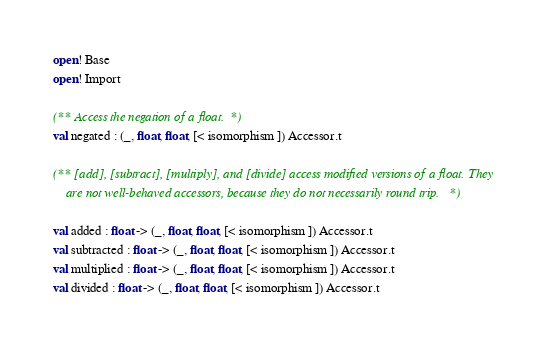<code> <loc_0><loc_0><loc_500><loc_500><_OCaml_>open! Base
open! Import

(** Access the negation of a float. *)
val negated : (_, float, float, [< isomorphism ]) Accessor.t

(** [add], [subtract], [multiply], and [divide] access modified versions of a float. They
    are not well-behaved accessors, because they do not necessarily round trip. *)

val added : float -> (_, float, float, [< isomorphism ]) Accessor.t
val subtracted : float -> (_, float, float, [< isomorphism ]) Accessor.t
val multiplied : float -> (_, float, float, [< isomorphism ]) Accessor.t
val divided : float -> (_, float, float, [< isomorphism ]) Accessor.t
</code> 